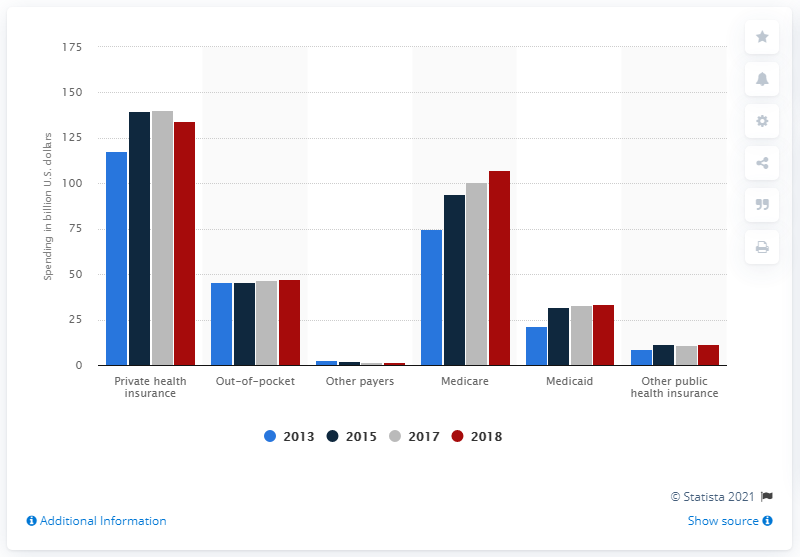Indicate a few pertinent items in this graphic. In 2018, private health insurance paid $134.3 billion for prescription drugs. 